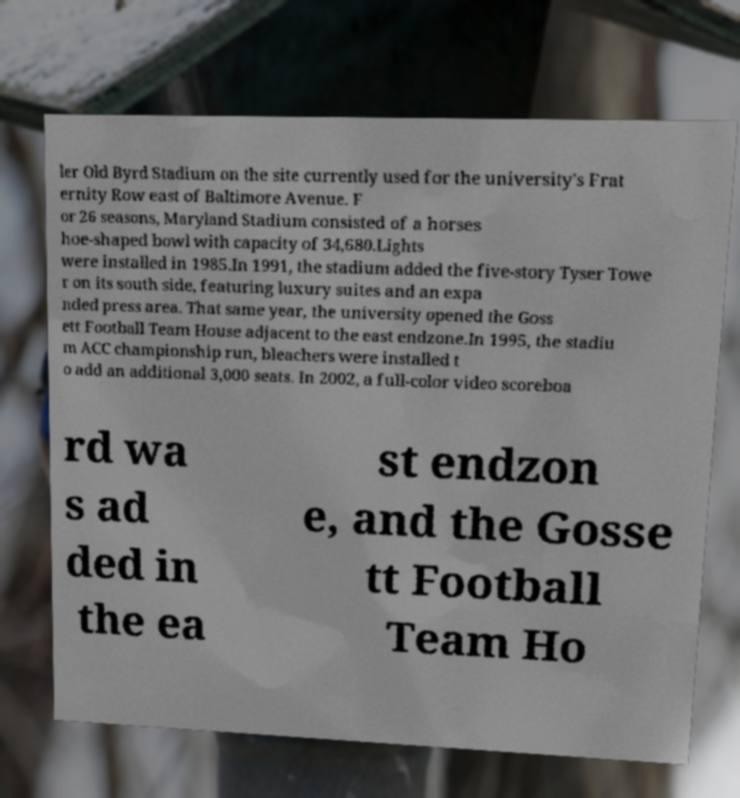Please read and relay the text visible in this image. What does it say? ler Old Byrd Stadium on the site currently used for the university's Frat ernity Row east of Baltimore Avenue. F or 26 seasons, Maryland Stadium consisted of a horses hoe-shaped bowl with capacity of 34,680.Lights were installed in 1985.In 1991, the stadium added the five-story Tyser Towe r on its south side, featuring luxury suites and an expa nded press area. That same year, the university opened the Goss ett Football Team House adjacent to the east endzone.In 1995, the stadiu m ACC championship run, bleachers were installed t o add an additional 3,000 seats. In 2002, a full-color video scoreboa rd wa s ad ded in the ea st endzon e, and the Gosse tt Football Team Ho 